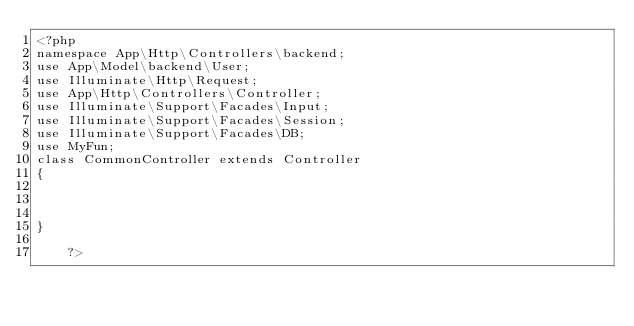Convert code to text. <code><loc_0><loc_0><loc_500><loc_500><_PHP_><?php
namespace App\Http\Controllers\backend;
use App\Model\backend\User;
use Illuminate\Http\Request;
use App\Http\Controllers\Controller;
use Illuminate\Support\Facades\Input;
use Illuminate\Support\Facades\Session;
use Illuminate\Support\Facades\DB;
use MyFun;
class CommonController extends Controller
{



}

	?></code> 